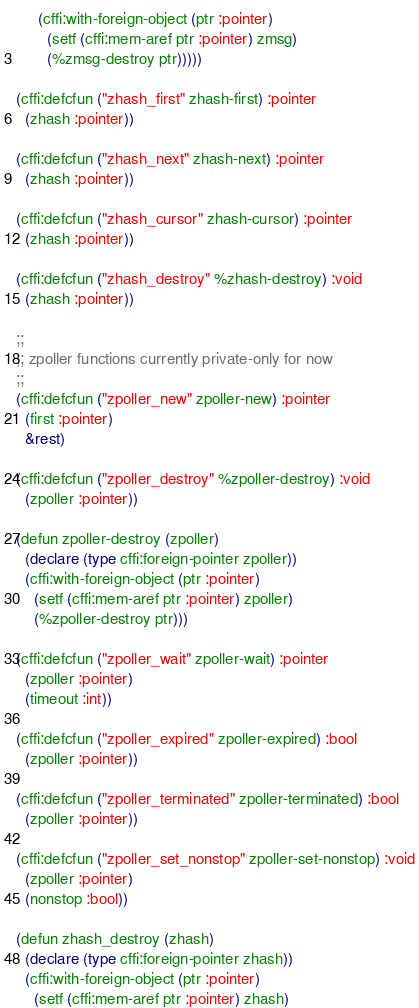Convert code to text. <code><loc_0><loc_0><loc_500><loc_500><_Lisp_>     (cffi:with-foreign-object (ptr :pointer)
       (setf (cffi:mem-aref ptr :pointer) zmsg)
       (%zmsg-destroy ptr)))))

(cffi:defcfun ("zhash_first" zhash-first) :pointer
  (zhash :pointer))

(cffi:defcfun ("zhash_next" zhash-next) :pointer
  (zhash :pointer))

(cffi:defcfun ("zhash_cursor" zhash-cursor) :pointer
  (zhash :pointer))

(cffi:defcfun ("zhash_destroy" %zhash-destroy) :void
  (zhash :pointer))

;;
;; zpoller functions currently private-only for now
;;
(cffi:defcfun ("zpoller_new" zpoller-new) :pointer
  (first :pointer)
  &rest)

(cffi:defcfun ("zpoller_destroy" %zpoller-destroy) :void
  (zpoller :pointer))

(defun zpoller-destroy (zpoller)
  (declare (type cffi:foreign-pointer zpoller))
  (cffi:with-foreign-object (ptr :pointer)
    (setf (cffi:mem-aref ptr :pointer) zpoller)
    (%zpoller-destroy ptr)))

(cffi:defcfun ("zpoller_wait" zpoller-wait) :pointer
  (zpoller :pointer)
  (timeout :int))

(cffi:defcfun ("zpoller_expired" zpoller-expired) :bool
  (zpoller :pointer))

(cffi:defcfun ("zpoller_terminated" zpoller-terminated) :bool
  (zpoller :pointer))

(cffi:defcfun ("zpoller_set_nonstop" zpoller-set-nonstop) :void
  (zpoller :pointer)
  (nonstop :bool))

(defun zhash_destroy (zhash)
  (declare (type cffi:foreign-pointer zhash))
  (cffi:with-foreign-object (ptr :pointer)
    (setf (cffi:mem-aref ptr :pointer) zhash)</code> 